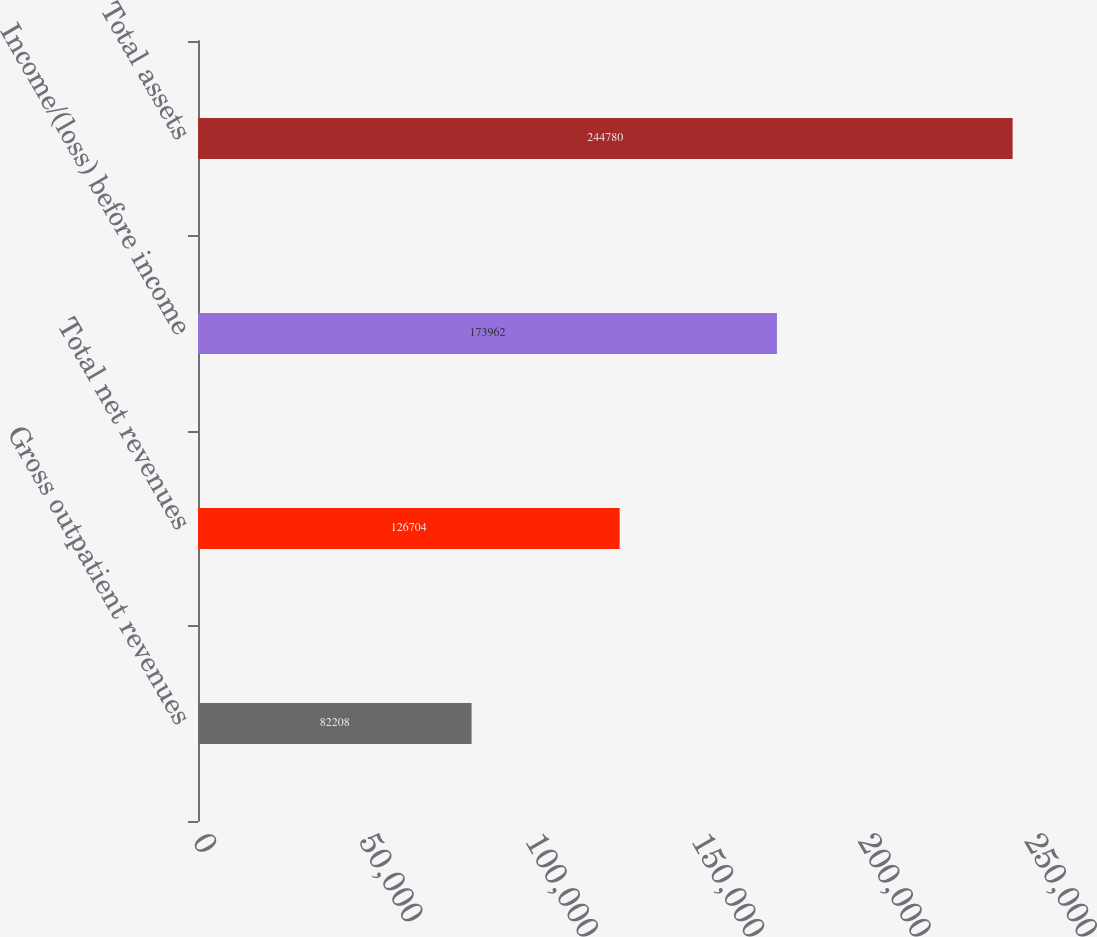Convert chart. <chart><loc_0><loc_0><loc_500><loc_500><bar_chart><fcel>Gross outpatient revenues<fcel>Total net revenues<fcel>Income/(loss) before income<fcel>Total assets<nl><fcel>82208<fcel>126704<fcel>173962<fcel>244780<nl></chart> 